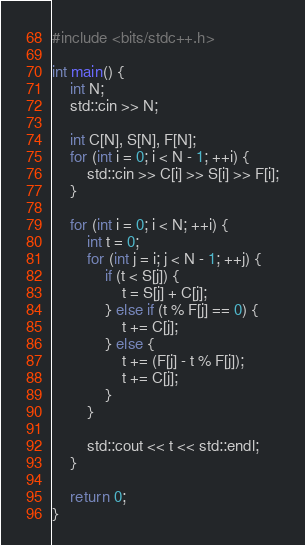<code> <loc_0><loc_0><loc_500><loc_500><_C++_>#include <bits/stdc++.h>

int main() {
    int N;
    std::cin >> N;

    int C[N], S[N], F[N];
    for (int i = 0; i < N - 1; ++i) {
        std::cin >> C[i] >> S[i] >> F[i];
    }

    for (int i = 0; i < N; ++i) {
        int t = 0;
        for (int j = i; j < N - 1; ++j) {
            if (t < S[j]) {
                t = S[j] + C[j];
            } else if (t % F[j] == 0) {
                t += C[j];
            } else {
                t += (F[j] - t % F[j]);
                t += C[j];
            }
        }

        std::cout << t << std::endl;
    }

    return 0;
}
</code> 